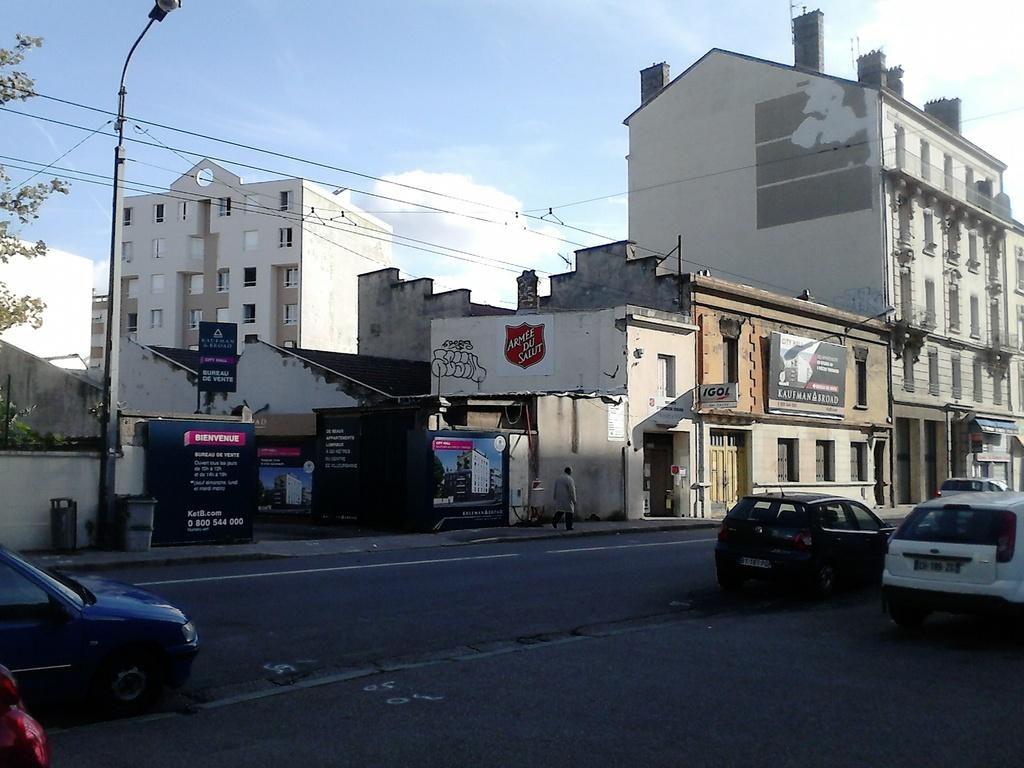What type of structures can be seen in the image? There are buildings with windows in the image. What is the purpose of the object on the side of the road? There is a street light in the image, which provides illumination at night. What can be found on the boards in the image? There are boards with text in the image, which may contain information or advertisements. What type of vegetation is present in the image? There is a tree in the image. What is moving along the road in the image? There are vehicles on the road in the image. How many babies are being measured in the image? There are no babies or measuring devices present in the image. What is the cause of the sore throat in the image? There is no mention of a sore throat or any medical condition in the image. 